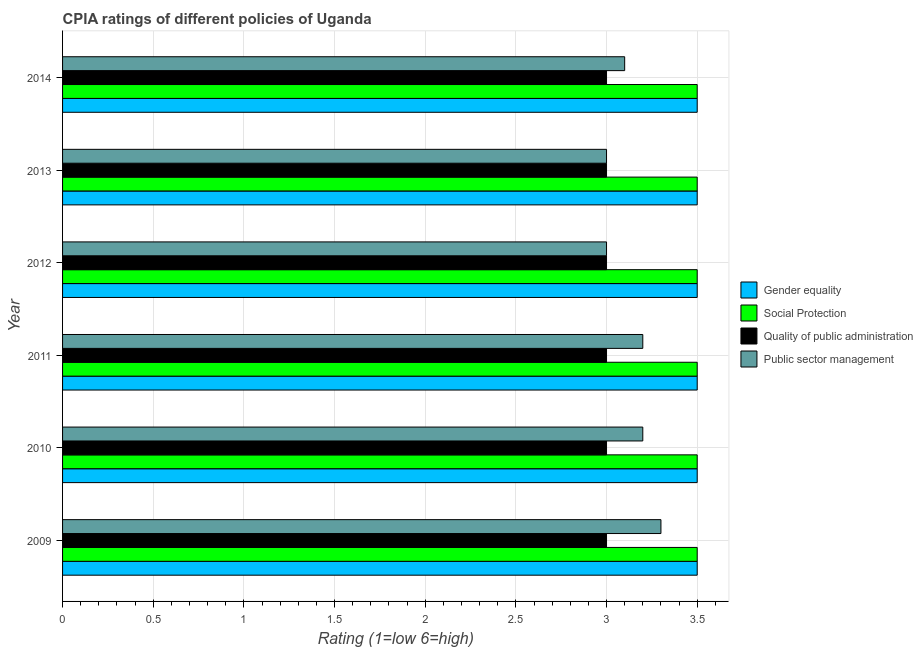Are the number of bars on each tick of the Y-axis equal?
Provide a succinct answer. Yes. How many bars are there on the 1st tick from the top?
Your answer should be compact. 4. How many bars are there on the 2nd tick from the bottom?
Offer a very short reply. 4. What is the cpia rating of public sector management in 2013?
Provide a succinct answer. 3. Across all years, what is the maximum cpia rating of public sector management?
Provide a short and direct response. 3.3. Across all years, what is the minimum cpia rating of quality of public administration?
Your answer should be compact. 3. What is the difference between the cpia rating of public sector management in 2009 and the cpia rating of gender equality in 2013?
Keep it short and to the point. -0.2. In the year 2010, what is the difference between the cpia rating of gender equality and cpia rating of public sector management?
Your answer should be very brief. 0.3. In how many years, is the cpia rating of social protection greater than 1.8 ?
Offer a terse response. 6. What is the ratio of the cpia rating of social protection in 2010 to that in 2012?
Provide a succinct answer. 1. What is the difference between the highest and the lowest cpia rating of social protection?
Offer a terse response. 0. In how many years, is the cpia rating of public sector management greater than the average cpia rating of public sector management taken over all years?
Ensure brevity in your answer.  3. Is the sum of the cpia rating of quality of public administration in 2009 and 2014 greater than the maximum cpia rating of public sector management across all years?
Make the answer very short. Yes. What does the 4th bar from the top in 2010 represents?
Offer a very short reply. Gender equality. What does the 2nd bar from the bottom in 2014 represents?
Make the answer very short. Social Protection. Is it the case that in every year, the sum of the cpia rating of gender equality and cpia rating of social protection is greater than the cpia rating of quality of public administration?
Provide a short and direct response. Yes. How many bars are there?
Give a very brief answer. 24. Are all the bars in the graph horizontal?
Offer a terse response. Yes. What is the difference between two consecutive major ticks on the X-axis?
Ensure brevity in your answer.  0.5. Does the graph contain any zero values?
Your response must be concise. No. Does the graph contain grids?
Give a very brief answer. Yes. How many legend labels are there?
Keep it short and to the point. 4. How are the legend labels stacked?
Make the answer very short. Vertical. What is the title of the graph?
Make the answer very short. CPIA ratings of different policies of Uganda. What is the label or title of the X-axis?
Your response must be concise. Rating (1=low 6=high). What is the label or title of the Y-axis?
Offer a very short reply. Year. What is the Rating (1=low 6=high) in Quality of public administration in 2009?
Provide a succinct answer. 3. What is the Rating (1=low 6=high) of Gender equality in 2010?
Give a very brief answer. 3.5. What is the Rating (1=low 6=high) of Quality of public administration in 2010?
Provide a short and direct response. 3. What is the Rating (1=low 6=high) of Gender equality in 2011?
Offer a very short reply. 3.5. What is the Rating (1=low 6=high) of Social Protection in 2011?
Your answer should be compact. 3.5. What is the Rating (1=low 6=high) in Public sector management in 2011?
Ensure brevity in your answer.  3.2. What is the Rating (1=low 6=high) of Social Protection in 2012?
Give a very brief answer. 3.5. What is the Rating (1=low 6=high) in Quality of public administration in 2012?
Offer a terse response. 3. What is the Rating (1=low 6=high) in Public sector management in 2012?
Provide a short and direct response. 3. What is the Rating (1=low 6=high) of Gender equality in 2013?
Provide a short and direct response. 3.5. What is the Rating (1=low 6=high) of Social Protection in 2013?
Ensure brevity in your answer.  3.5. What is the Rating (1=low 6=high) of Quality of public administration in 2014?
Your answer should be compact. 3. What is the Rating (1=low 6=high) of Public sector management in 2014?
Keep it short and to the point. 3.1. Across all years, what is the maximum Rating (1=low 6=high) of Gender equality?
Offer a terse response. 3.5. Across all years, what is the maximum Rating (1=low 6=high) of Social Protection?
Keep it short and to the point. 3.5. Across all years, what is the maximum Rating (1=low 6=high) in Quality of public administration?
Your response must be concise. 3. Across all years, what is the maximum Rating (1=low 6=high) in Public sector management?
Give a very brief answer. 3.3. Across all years, what is the minimum Rating (1=low 6=high) of Gender equality?
Make the answer very short. 3.5. Across all years, what is the minimum Rating (1=low 6=high) in Social Protection?
Provide a succinct answer. 3.5. Across all years, what is the minimum Rating (1=low 6=high) of Quality of public administration?
Offer a terse response. 3. What is the total Rating (1=low 6=high) in Social Protection in the graph?
Ensure brevity in your answer.  21. What is the total Rating (1=low 6=high) of Public sector management in the graph?
Ensure brevity in your answer.  18.8. What is the difference between the Rating (1=low 6=high) in Quality of public administration in 2009 and that in 2010?
Give a very brief answer. 0. What is the difference between the Rating (1=low 6=high) in Public sector management in 2009 and that in 2010?
Make the answer very short. 0.1. What is the difference between the Rating (1=low 6=high) of Gender equality in 2009 and that in 2011?
Ensure brevity in your answer.  0. What is the difference between the Rating (1=low 6=high) of Social Protection in 2009 and that in 2011?
Provide a short and direct response. 0. What is the difference between the Rating (1=low 6=high) in Public sector management in 2009 and that in 2011?
Offer a very short reply. 0.1. What is the difference between the Rating (1=low 6=high) of Social Protection in 2009 and that in 2013?
Your answer should be compact. 0. What is the difference between the Rating (1=low 6=high) in Gender equality in 2009 and that in 2014?
Provide a short and direct response. 0. What is the difference between the Rating (1=low 6=high) in Social Protection in 2009 and that in 2014?
Ensure brevity in your answer.  0. What is the difference between the Rating (1=low 6=high) in Public sector management in 2009 and that in 2014?
Your answer should be very brief. 0.2. What is the difference between the Rating (1=low 6=high) in Gender equality in 2010 and that in 2011?
Provide a succinct answer. 0. What is the difference between the Rating (1=low 6=high) in Quality of public administration in 2010 and that in 2011?
Ensure brevity in your answer.  0. What is the difference between the Rating (1=low 6=high) in Public sector management in 2010 and that in 2011?
Your answer should be very brief. 0. What is the difference between the Rating (1=low 6=high) in Social Protection in 2010 and that in 2012?
Provide a succinct answer. 0. What is the difference between the Rating (1=low 6=high) of Social Protection in 2010 and that in 2013?
Keep it short and to the point. 0. What is the difference between the Rating (1=low 6=high) of Quality of public administration in 2010 and that in 2013?
Your response must be concise. 0. What is the difference between the Rating (1=low 6=high) in Public sector management in 2010 and that in 2014?
Your answer should be compact. 0.1. What is the difference between the Rating (1=low 6=high) of Gender equality in 2011 and that in 2012?
Offer a very short reply. 0. What is the difference between the Rating (1=low 6=high) in Quality of public administration in 2011 and that in 2012?
Your answer should be very brief. 0. What is the difference between the Rating (1=low 6=high) of Social Protection in 2011 and that in 2013?
Ensure brevity in your answer.  0. What is the difference between the Rating (1=low 6=high) of Quality of public administration in 2011 and that in 2013?
Ensure brevity in your answer.  0. What is the difference between the Rating (1=low 6=high) in Gender equality in 2011 and that in 2014?
Your response must be concise. 0. What is the difference between the Rating (1=low 6=high) in Social Protection in 2011 and that in 2014?
Offer a very short reply. 0. What is the difference between the Rating (1=low 6=high) in Quality of public administration in 2011 and that in 2014?
Your answer should be compact. 0. What is the difference between the Rating (1=low 6=high) of Public sector management in 2011 and that in 2014?
Offer a very short reply. 0.1. What is the difference between the Rating (1=low 6=high) in Quality of public administration in 2012 and that in 2013?
Make the answer very short. 0. What is the difference between the Rating (1=low 6=high) of Public sector management in 2012 and that in 2013?
Give a very brief answer. 0. What is the difference between the Rating (1=low 6=high) of Social Protection in 2012 and that in 2014?
Offer a terse response. 0. What is the difference between the Rating (1=low 6=high) of Quality of public administration in 2012 and that in 2014?
Ensure brevity in your answer.  0. What is the difference between the Rating (1=low 6=high) in Gender equality in 2013 and that in 2014?
Provide a short and direct response. 0. What is the difference between the Rating (1=low 6=high) in Quality of public administration in 2013 and that in 2014?
Provide a short and direct response. 0. What is the difference between the Rating (1=low 6=high) in Gender equality in 2009 and the Rating (1=low 6=high) in Quality of public administration in 2010?
Your answer should be very brief. 0.5. What is the difference between the Rating (1=low 6=high) of Gender equality in 2009 and the Rating (1=low 6=high) of Public sector management in 2010?
Keep it short and to the point. 0.3. What is the difference between the Rating (1=low 6=high) in Quality of public administration in 2009 and the Rating (1=low 6=high) in Public sector management in 2010?
Give a very brief answer. -0.2. What is the difference between the Rating (1=low 6=high) of Gender equality in 2009 and the Rating (1=low 6=high) of Social Protection in 2011?
Offer a terse response. 0. What is the difference between the Rating (1=low 6=high) of Gender equality in 2009 and the Rating (1=low 6=high) of Quality of public administration in 2011?
Provide a short and direct response. 0.5. What is the difference between the Rating (1=low 6=high) in Social Protection in 2009 and the Rating (1=low 6=high) in Public sector management in 2011?
Your answer should be compact. 0.3. What is the difference between the Rating (1=low 6=high) in Quality of public administration in 2009 and the Rating (1=low 6=high) in Public sector management in 2011?
Provide a succinct answer. -0.2. What is the difference between the Rating (1=low 6=high) in Gender equality in 2009 and the Rating (1=low 6=high) in Social Protection in 2012?
Your answer should be compact. 0. What is the difference between the Rating (1=low 6=high) in Gender equality in 2009 and the Rating (1=low 6=high) in Quality of public administration in 2012?
Your answer should be compact. 0.5. What is the difference between the Rating (1=low 6=high) of Gender equality in 2009 and the Rating (1=low 6=high) of Public sector management in 2012?
Keep it short and to the point. 0.5. What is the difference between the Rating (1=low 6=high) in Social Protection in 2009 and the Rating (1=low 6=high) in Public sector management in 2012?
Keep it short and to the point. 0.5. What is the difference between the Rating (1=low 6=high) in Gender equality in 2009 and the Rating (1=low 6=high) in Quality of public administration in 2013?
Provide a succinct answer. 0.5. What is the difference between the Rating (1=low 6=high) in Social Protection in 2009 and the Rating (1=low 6=high) in Quality of public administration in 2013?
Provide a succinct answer. 0.5. What is the difference between the Rating (1=low 6=high) in Social Protection in 2009 and the Rating (1=low 6=high) in Public sector management in 2013?
Offer a terse response. 0.5. What is the difference between the Rating (1=low 6=high) of Gender equality in 2009 and the Rating (1=low 6=high) of Social Protection in 2014?
Offer a very short reply. 0. What is the difference between the Rating (1=low 6=high) in Quality of public administration in 2009 and the Rating (1=low 6=high) in Public sector management in 2014?
Make the answer very short. -0.1. What is the difference between the Rating (1=low 6=high) of Gender equality in 2010 and the Rating (1=low 6=high) of Social Protection in 2011?
Make the answer very short. 0. What is the difference between the Rating (1=low 6=high) in Social Protection in 2010 and the Rating (1=low 6=high) in Quality of public administration in 2011?
Give a very brief answer. 0.5. What is the difference between the Rating (1=low 6=high) in Social Protection in 2010 and the Rating (1=low 6=high) in Public sector management in 2011?
Offer a terse response. 0.3. What is the difference between the Rating (1=low 6=high) of Quality of public administration in 2010 and the Rating (1=low 6=high) of Public sector management in 2011?
Offer a terse response. -0.2. What is the difference between the Rating (1=low 6=high) of Gender equality in 2010 and the Rating (1=low 6=high) of Public sector management in 2012?
Ensure brevity in your answer.  0.5. What is the difference between the Rating (1=low 6=high) of Social Protection in 2010 and the Rating (1=low 6=high) of Quality of public administration in 2012?
Your response must be concise. 0.5. What is the difference between the Rating (1=low 6=high) of Gender equality in 2010 and the Rating (1=low 6=high) of Social Protection in 2013?
Your answer should be compact. 0. What is the difference between the Rating (1=low 6=high) in Gender equality in 2010 and the Rating (1=low 6=high) in Quality of public administration in 2013?
Your response must be concise. 0.5. What is the difference between the Rating (1=low 6=high) in Gender equality in 2010 and the Rating (1=low 6=high) in Public sector management in 2013?
Your answer should be compact. 0.5. What is the difference between the Rating (1=low 6=high) of Quality of public administration in 2010 and the Rating (1=low 6=high) of Public sector management in 2013?
Provide a short and direct response. 0. What is the difference between the Rating (1=low 6=high) of Gender equality in 2010 and the Rating (1=low 6=high) of Social Protection in 2014?
Keep it short and to the point. 0. What is the difference between the Rating (1=low 6=high) of Gender equality in 2010 and the Rating (1=low 6=high) of Quality of public administration in 2014?
Keep it short and to the point. 0.5. What is the difference between the Rating (1=low 6=high) of Gender equality in 2010 and the Rating (1=low 6=high) of Public sector management in 2014?
Give a very brief answer. 0.4. What is the difference between the Rating (1=low 6=high) of Social Protection in 2010 and the Rating (1=low 6=high) of Quality of public administration in 2014?
Provide a succinct answer. 0.5. What is the difference between the Rating (1=low 6=high) in Gender equality in 2011 and the Rating (1=low 6=high) in Public sector management in 2012?
Offer a terse response. 0.5. What is the difference between the Rating (1=low 6=high) of Social Protection in 2011 and the Rating (1=low 6=high) of Quality of public administration in 2012?
Make the answer very short. 0.5. What is the difference between the Rating (1=low 6=high) in Social Protection in 2011 and the Rating (1=low 6=high) in Public sector management in 2012?
Keep it short and to the point. 0.5. What is the difference between the Rating (1=low 6=high) of Quality of public administration in 2011 and the Rating (1=low 6=high) of Public sector management in 2012?
Make the answer very short. 0. What is the difference between the Rating (1=low 6=high) of Social Protection in 2011 and the Rating (1=low 6=high) of Quality of public administration in 2013?
Your answer should be compact. 0.5. What is the difference between the Rating (1=low 6=high) in Social Protection in 2011 and the Rating (1=low 6=high) in Public sector management in 2013?
Your answer should be very brief. 0.5. What is the difference between the Rating (1=low 6=high) in Gender equality in 2011 and the Rating (1=low 6=high) in Social Protection in 2014?
Provide a short and direct response. 0. What is the difference between the Rating (1=low 6=high) of Social Protection in 2011 and the Rating (1=low 6=high) of Public sector management in 2014?
Keep it short and to the point. 0.4. What is the difference between the Rating (1=low 6=high) in Gender equality in 2012 and the Rating (1=low 6=high) in Social Protection in 2013?
Your answer should be very brief. 0. What is the difference between the Rating (1=low 6=high) of Social Protection in 2012 and the Rating (1=low 6=high) of Quality of public administration in 2013?
Make the answer very short. 0.5. What is the difference between the Rating (1=low 6=high) of Quality of public administration in 2012 and the Rating (1=low 6=high) of Public sector management in 2013?
Your answer should be very brief. 0. What is the difference between the Rating (1=low 6=high) in Gender equality in 2012 and the Rating (1=low 6=high) in Social Protection in 2014?
Your answer should be compact. 0. What is the difference between the Rating (1=low 6=high) of Gender equality in 2012 and the Rating (1=low 6=high) of Quality of public administration in 2014?
Offer a terse response. 0.5. What is the difference between the Rating (1=low 6=high) of Gender equality in 2012 and the Rating (1=low 6=high) of Public sector management in 2014?
Your response must be concise. 0.4. What is the difference between the Rating (1=low 6=high) in Quality of public administration in 2012 and the Rating (1=low 6=high) in Public sector management in 2014?
Provide a short and direct response. -0.1. What is the difference between the Rating (1=low 6=high) in Gender equality in 2013 and the Rating (1=low 6=high) in Social Protection in 2014?
Give a very brief answer. 0. What is the difference between the Rating (1=low 6=high) in Gender equality in 2013 and the Rating (1=low 6=high) in Quality of public administration in 2014?
Offer a very short reply. 0.5. What is the average Rating (1=low 6=high) in Quality of public administration per year?
Your answer should be very brief. 3. What is the average Rating (1=low 6=high) of Public sector management per year?
Provide a succinct answer. 3.13. In the year 2009, what is the difference between the Rating (1=low 6=high) in Gender equality and Rating (1=low 6=high) in Social Protection?
Offer a very short reply. 0. In the year 2009, what is the difference between the Rating (1=low 6=high) of Gender equality and Rating (1=low 6=high) of Quality of public administration?
Ensure brevity in your answer.  0.5. In the year 2009, what is the difference between the Rating (1=low 6=high) in Gender equality and Rating (1=low 6=high) in Public sector management?
Give a very brief answer. 0.2. In the year 2009, what is the difference between the Rating (1=low 6=high) of Social Protection and Rating (1=low 6=high) of Public sector management?
Ensure brevity in your answer.  0.2. In the year 2009, what is the difference between the Rating (1=low 6=high) of Quality of public administration and Rating (1=low 6=high) of Public sector management?
Make the answer very short. -0.3. In the year 2010, what is the difference between the Rating (1=low 6=high) in Gender equality and Rating (1=low 6=high) in Social Protection?
Ensure brevity in your answer.  0. In the year 2010, what is the difference between the Rating (1=low 6=high) of Gender equality and Rating (1=low 6=high) of Public sector management?
Provide a succinct answer. 0.3. In the year 2010, what is the difference between the Rating (1=low 6=high) in Social Protection and Rating (1=low 6=high) in Quality of public administration?
Offer a terse response. 0.5. In the year 2011, what is the difference between the Rating (1=low 6=high) in Social Protection and Rating (1=low 6=high) in Quality of public administration?
Ensure brevity in your answer.  0.5. In the year 2011, what is the difference between the Rating (1=low 6=high) of Social Protection and Rating (1=low 6=high) of Public sector management?
Give a very brief answer. 0.3. In the year 2011, what is the difference between the Rating (1=low 6=high) in Quality of public administration and Rating (1=low 6=high) in Public sector management?
Your response must be concise. -0.2. In the year 2012, what is the difference between the Rating (1=low 6=high) in Gender equality and Rating (1=low 6=high) in Quality of public administration?
Provide a short and direct response. 0.5. In the year 2012, what is the difference between the Rating (1=low 6=high) in Gender equality and Rating (1=low 6=high) in Public sector management?
Your answer should be compact. 0.5. In the year 2012, what is the difference between the Rating (1=low 6=high) of Quality of public administration and Rating (1=low 6=high) of Public sector management?
Make the answer very short. 0. In the year 2013, what is the difference between the Rating (1=low 6=high) of Gender equality and Rating (1=low 6=high) of Social Protection?
Give a very brief answer. 0. In the year 2013, what is the difference between the Rating (1=low 6=high) of Gender equality and Rating (1=low 6=high) of Quality of public administration?
Your answer should be compact. 0.5. In the year 2013, what is the difference between the Rating (1=low 6=high) of Social Protection and Rating (1=low 6=high) of Quality of public administration?
Your response must be concise. 0.5. In the year 2013, what is the difference between the Rating (1=low 6=high) of Social Protection and Rating (1=low 6=high) of Public sector management?
Keep it short and to the point. 0.5. In the year 2013, what is the difference between the Rating (1=low 6=high) in Quality of public administration and Rating (1=low 6=high) in Public sector management?
Your answer should be very brief. 0. In the year 2014, what is the difference between the Rating (1=low 6=high) in Gender equality and Rating (1=low 6=high) in Quality of public administration?
Give a very brief answer. 0.5. In the year 2014, what is the difference between the Rating (1=low 6=high) in Gender equality and Rating (1=low 6=high) in Public sector management?
Offer a very short reply. 0.4. In the year 2014, what is the difference between the Rating (1=low 6=high) in Social Protection and Rating (1=low 6=high) in Quality of public administration?
Ensure brevity in your answer.  0.5. In the year 2014, what is the difference between the Rating (1=low 6=high) of Quality of public administration and Rating (1=low 6=high) of Public sector management?
Provide a short and direct response. -0.1. What is the ratio of the Rating (1=low 6=high) in Gender equality in 2009 to that in 2010?
Provide a succinct answer. 1. What is the ratio of the Rating (1=low 6=high) of Social Protection in 2009 to that in 2010?
Your answer should be very brief. 1. What is the ratio of the Rating (1=low 6=high) in Quality of public administration in 2009 to that in 2010?
Offer a very short reply. 1. What is the ratio of the Rating (1=low 6=high) in Public sector management in 2009 to that in 2010?
Your response must be concise. 1.03. What is the ratio of the Rating (1=low 6=high) in Social Protection in 2009 to that in 2011?
Ensure brevity in your answer.  1. What is the ratio of the Rating (1=low 6=high) in Public sector management in 2009 to that in 2011?
Keep it short and to the point. 1.03. What is the ratio of the Rating (1=low 6=high) in Social Protection in 2009 to that in 2012?
Your response must be concise. 1. What is the ratio of the Rating (1=low 6=high) of Public sector management in 2009 to that in 2012?
Provide a succinct answer. 1.1. What is the ratio of the Rating (1=low 6=high) of Quality of public administration in 2009 to that in 2013?
Your answer should be very brief. 1. What is the ratio of the Rating (1=low 6=high) of Quality of public administration in 2009 to that in 2014?
Your answer should be very brief. 1. What is the ratio of the Rating (1=low 6=high) in Public sector management in 2009 to that in 2014?
Give a very brief answer. 1.06. What is the ratio of the Rating (1=low 6=high) in Social Protection in 2010 to that in 2011?
Offer a terse response. 1. What is the ratio of the Rating (1=low 6=high) of Quality of public administration in 2010 to that in 2011?
Provide a short and direct response. 1. What is the ratio of the Rating (1=low 6=high) in Gender equality in 2010 to that in 2012?
Your answer should be compact. 1. What is the ratio of the Rating (1=low 6=high) of Social Protection in 2010 to that in 2012?
Give a very brief answer. 1. What is the ratio of the Rating (1=low 6=high) of Public sector management in 2010 to that in 2012?
Make the answer very short. 1.07. What is the ratio of the Rating (1=low 6=high) of Social Protection in 2010 to that in 2013?
Your answer should be compact. 1. What is the ratio of the Rating (1=low 6=high) in Quality of public administration in 2010 to that in 2013?
Your answer should be compact. 1. What is the ratio of the Rating (1=low 6=high) in Public sector management in 2010 to that in 2013?
Your answer should be very brief. 1.07. What is the ratio of the Rating (1=low 6=high) of Public sector management in 2010 to that in 2014?
Your answer should be very brief. 1.03. What is the ratio of the Rating (1=low 6=high) of Gender equality in 2011 to that in 2012?
Your answer should be very brief. 1. What is the ratio of the Rating (1=low 6=high) in Quality of public administration in 2011 to that in 2012?
Provide a succinct answer. 1. What is the ratio of the Rating (1=low 6=high) in Public sector management in 2011 to that in 2012?
Give a very brief answer. 1.07. What is the ratio of the Rating (1=low 6=high) in Gender equality in 2011 to that in 2013?
Your answer should be compact. 1. What is the ratio of the Rating (1=low 6=high) in Social Protection in 2011 to that in 2013?
Make the answer very short. 1. What is the ratio of the Rating (1=low 6=high) of Public sector management in 2011 to that in 2013?
Your answer should be very brief. 1.07. What is the ratio of the Rating (1=low 6=high) in Social Protection in 2011 to that in 2014?
Keep it short and to the point. 1. What is the ratio of the Rating (1=low 6=high) of Public sector management in 2011 to that in 2014?
Provide a succinct answer. 1.03. What is the ratio of the Rating (1=low 6=high) of Gender equality in 2012 to that in 2013?
Give a very brief answer. 1. What is the ratio of the Rating (1=low 6=high) in Social Protection in 2012 to that in 2013?
Offer a very short reply. 1. What is the ratio of the Rating (1=low 6=high) of Social Protection in 2012 to that in 2014?
Keep it short and to the point. 1. What is the ratio of the Rating (1=low 6=high) in Quality of public administration in 2012 to that in 2014?
Your answer should be compact. 1. What is the ratio of the Rating (1=low 6=high) of Public sector management in 2012 to that in 2014?
Provide a succinct answer. 0.97. What is the ratio of the Rating (1=low 6=high) of Gender equality in 2013 to that in 2014?
Your answer should be compact. 1. What is the ratio of the Rating (1=low 6=high) of Public sector management in 2013 to that in 2014?
Offer a very short reply. 0.97. What is the difference between the highest and the second highest Rating (1=low 6=high) in Gender equality?
Offer a terse response. 0. What is the difference between the highest and the second highest Rating (1=low 6=high) in Public sector management?
Provide a short and direct response. 0.1. 